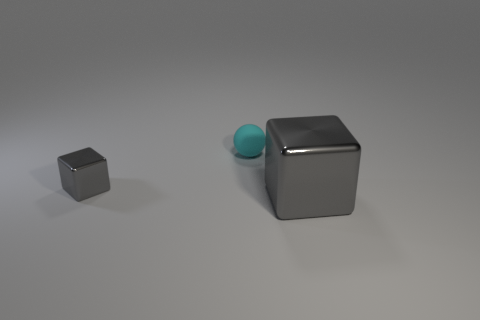Is there any other thing that has the same color as the small matte object?
Your response must be concise. No. How many things are either cubes behind the large gray metal object or tiny objects that are to the left of the small cyan matte sphere?
Provide a succinct answer. 1. Do the large metal block and the tiny shiny cube have the same color?
Offer a terse response. Yes. Are there fewer large gray cubes than yellow matte cylinders?
Provide a short and direct response. No. There is a ball; are there any large gray shiny cubes left of it?
Provide a succinct answer. No. Is the ball made of the same material as the small gray object?
Offer a very short reply. No. What color is the other object that is the same shape as the tiny gray object?
Provide a succinct answer. Gray. Is the color of the metal block that is to the left of the tiny rubber object the same as the large metal block?
Your answer should be compact. Yes. There is a tiny metallic thing that is the same color as the big metal object; what shape is it?
Provide a succinct answer. Cube. How many small cubes have the same material as the small cyan sphere?
Provide a short and direct response. 0. 